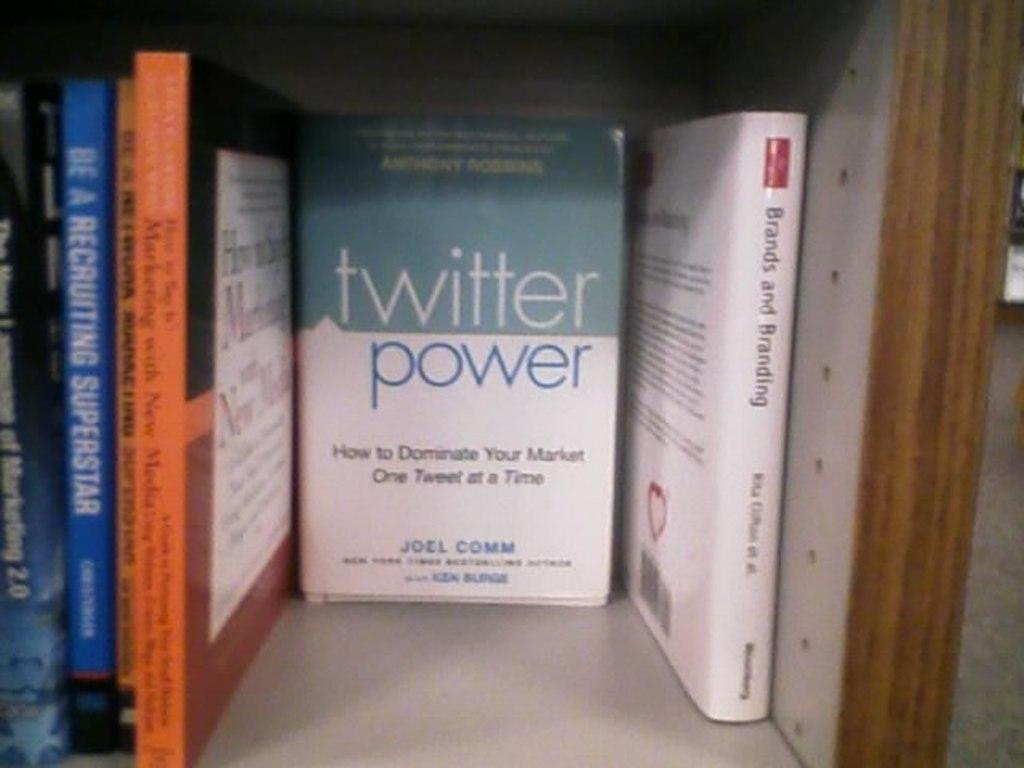<image>
Provide a brief description of the given image. A book called Twitter Power was written by Joel Comm and sits on a shelf among other books. 